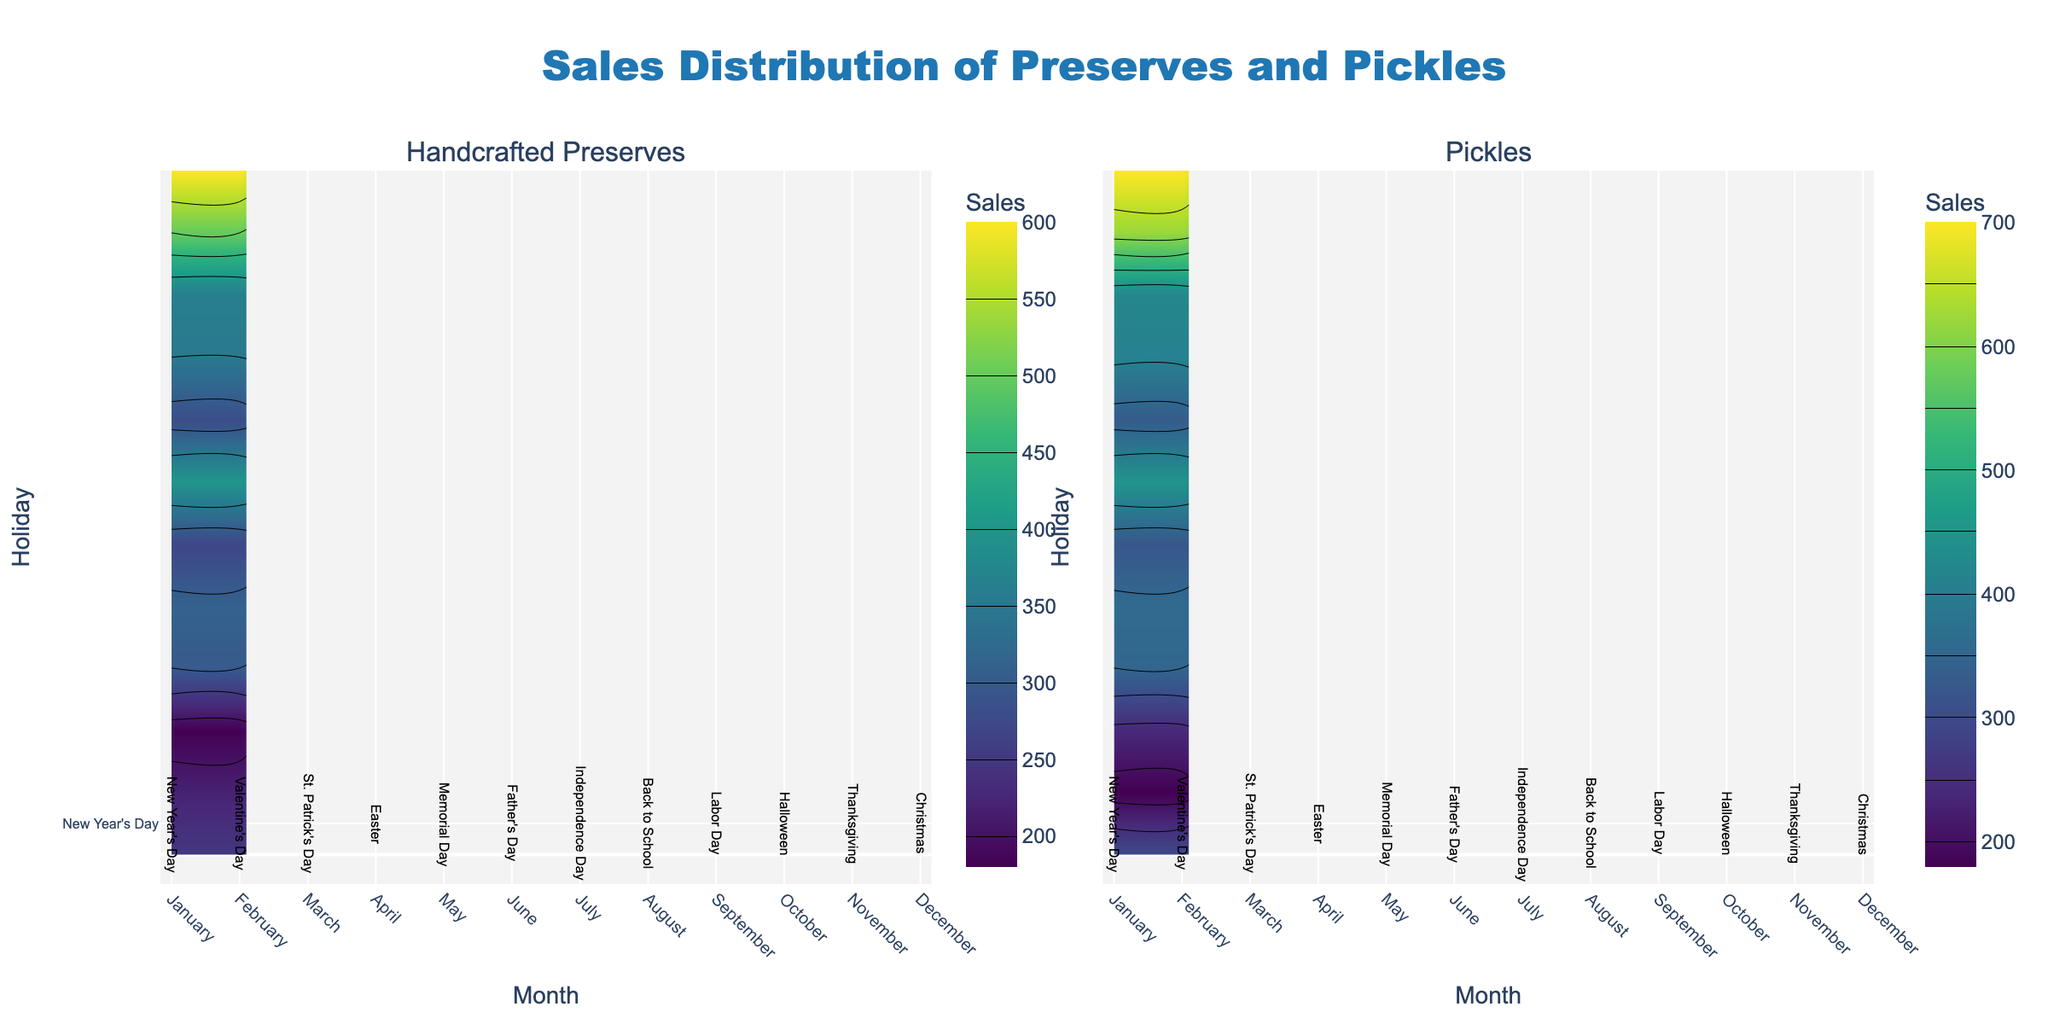Which month shows the highest sales for handcrafted preserves? The highest sales value for handcrafted preserves can be seen in December, indicated by the color intensity on the contour plot.
Answer: December How do the sales of pickles during Easter compare to those during Thanksgiving? Looking at the contour plot for pickles, the sales during Easter (April) are lower than during Thanksgiving (November). Specifically, Easter has around 350 sales, while Thanksgiving has around 620, as indicated by the color gradient.
Answer: Lower What is the average sales volume of pickles for the months from June to August? For June, July, and August, the sales volumes are 320, 450, and 330 respectively. Adding them up gives 1100. Dividing by 3 (the number of months) gives the average: 1100 / 3 = approximately 367.
Answer: Approx. 367 Which holiday corresponds with the highest sales of preserves? Observing the contour plot for handcrafted preserves, the highest sales are in December, which corresponds to Christmas.
Answer: Christmas Are handcrafted preserves sales more consistent across the months compared to pickles? By visually inspecting the contour plots for both handcrafted preserves and pickles, the contour lines (color gradients) for preserves show less fluctuation in intensity compared to pickles. This implies more consistent sales for preserves.
Answer: Yes Which period shows a significant increase in pickles sales compared to the previous month? Comparing color intensities, the period from October (Halloween) to November (Thanksgiving) shows a significant increase in pickles sales, rising from around 420 to 620.
Answer: October to November Do sales of handcrafted preserves peak around a major holiday? The highest sales in handcrafted preserves occur in December for Christmas, a major holiday. The contour plot confirms a peak during this period.
Answer: Yes Is there any month where both handcrafted preserves and pickles sales are equally high? November shows the highest sales for both handcrafted preserves and pickles, with sales values of 500 and 620, respectively.
Answer: November What is the increase in handcrafted preserves sales from May to July? Handcrafted preserves sales in May are 310, while in July they are 400. The increase is 400 - 310 = 90.
Answer: 90 